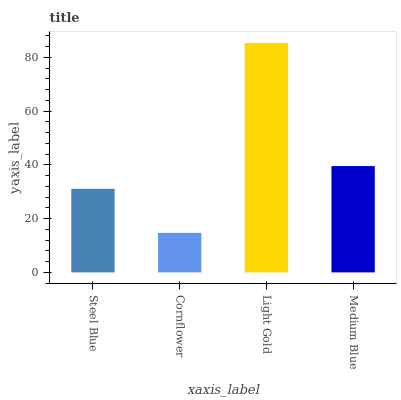Is Cornflower the minimum?
Answer yes or no. Yes. Is Light Gold the maximum?
Answer yes or no. Yes. Is Light Gold the minimum?
Answer yes or no. No. Is Cornflower the maximum?
Answer yes or no. No. Is Light Gold greater than Cornflower?
Answer yes or no. Yes. Is Cornflower less than Light Gold?
Answer yes or no. Yes. Is Cornflower greater than Light Gold?
Answer yes or no. No. Is Light Gold less than Cornflower?
Answer yes or no. No. Is Medium Blue the high median?
Answer yes or no. Yes. Is Steel Blue the low median?
Answer yes or no. Yes. Is Steel Blue the high median?
Answer yes or no. No. Is Cornflower the low median?
Answer yes or no. No. 